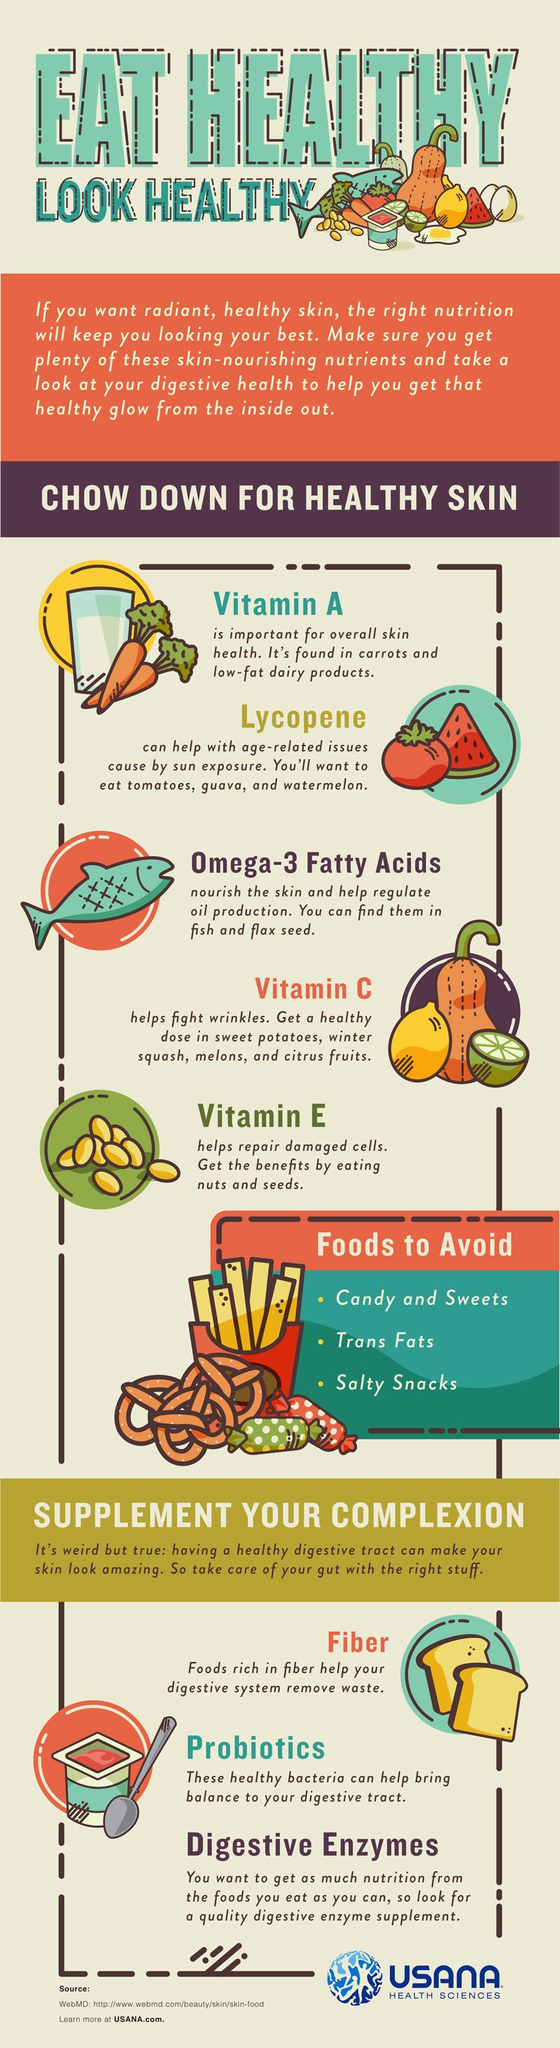Give some essential details in this illustration. Vitamins A, C, and E are essential for maintaining healthy skin. 